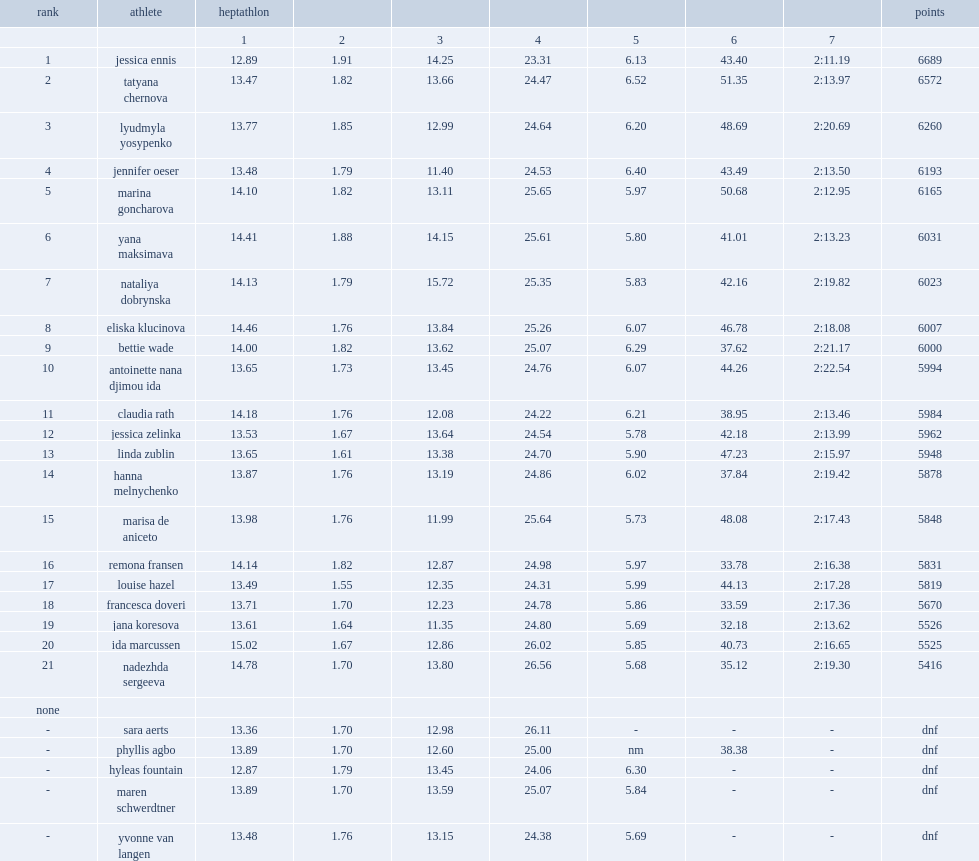What was the number of points of ennis? 6689.0. 